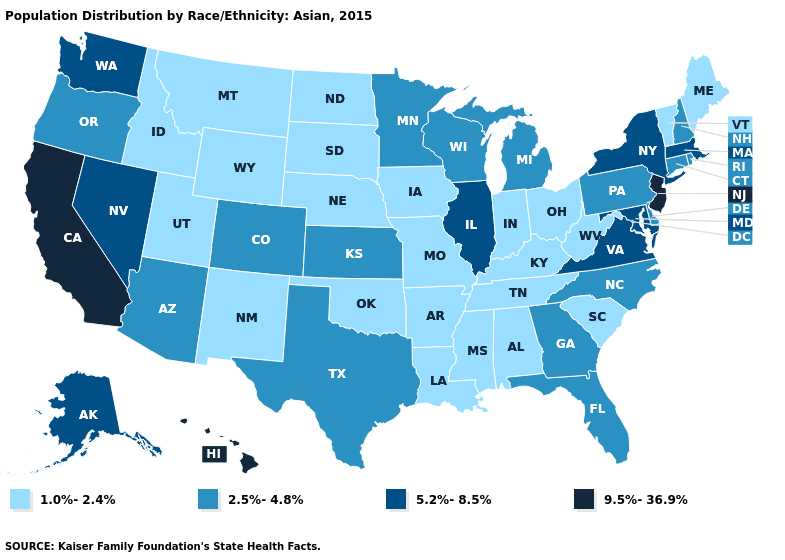Among the states that border Minnesota , does North Dakota have the highest value?
Answer briefly. No. What is the value of Idaho?
Answer briefly. 1.0%-2.4%. Name the states that have a value in the range 1.0%-2.4%?
Give a very brief answer. Alabama, Arkansas, Idaho, Indiana, Iowa, Kentucky, Louisiana, Maine, Mississippi, Missouri, Montana, Nebraska, New Mexico, North Dakota, Ohio, Oklahoma, South Carolina, South Dakota, Tennessee, Utah, Vermont, West Virginia, Wyoming. Name the states that have a value in the range 9.5%-36.9%?
Keep it brief. California, Hawaii, New Jersey. What is the value of Connecticut?
Keep it brief. 2.5%-4.8%. Name the states that have a value in the range 5.2%-8.5%?
Write a very short answer. Alaska, Illinois, Maryland, Massachusetts, Nevada, New York, Virginia, Washington. What is the lowest value in states that border New York?
Answer briefly. 1.0%-2.4%. Name the states that have a value in the range 5.2%-8.5%?
Write a very short answer. Alaska, Illinois, Maryland, Massachusetts, Nevada, New York, Virginia, Washington. Does Georgia have a lower value than Michigan?
Be succinct. No. What is the highest value in states that border Louisiana?
Answer briefly. 2.5%-4.8%. Does California have the highest value in the West?
Quick response, please. Yes. Does Ohio have the lowest value in the USA?
Keep it brief. Yes. Does Illinois have the highest value in the MidWest?
Be succinct. Yes. Name the states that have a value in the range 9.5%-36.9%?
Be succinct. California, Hawaii, New Jersey. 